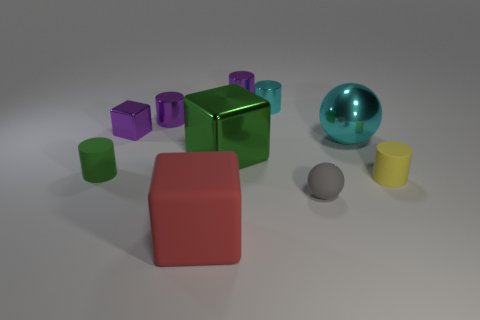There is a small cube; is its color the same as the tiny shiny thing behind the cyan cylinder?
Ensure brevity in your answer.  Yes. The small metal thing that is the same color as the large ball is what shape?
Your response must be concise. Cylinder. What number of objects are small purple metallic cylinders to the right of the big rubber cube or rubber cylinders that are on the right side of the red cube?
Offer a terse response. 2. How many large metallic objects have the same shape as the red matte thing?
Keep it short and to the point. 1. What is the color of the rubber cube that is the same size as the cyan metallic ball?
Provide a succinct answer. Red. There is a small rubber cylinder that is on the right side of the rubber thing that is behind the tiny thing right of the matte ball; what is its color?
Provide a short and direct response. Yellow. There is a red cube; is its size the same as the rubber cylinder that is in front of the tiny green thing?
Provide a short and direct response. No. What number of things are small blue matte cylinders or gray rubber things?
Your answer should be compact. 1. Is there a large purple cube made of the same material as the large green thing?
Give a very brief answer. No. What size is the cylinder that is the same color as the big sphere?
Offer a terse response. Small. 